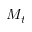Convert formula to latex. <formula><loc_0><loc_0><loc_500><loc_500>M _ { t }</formula> 